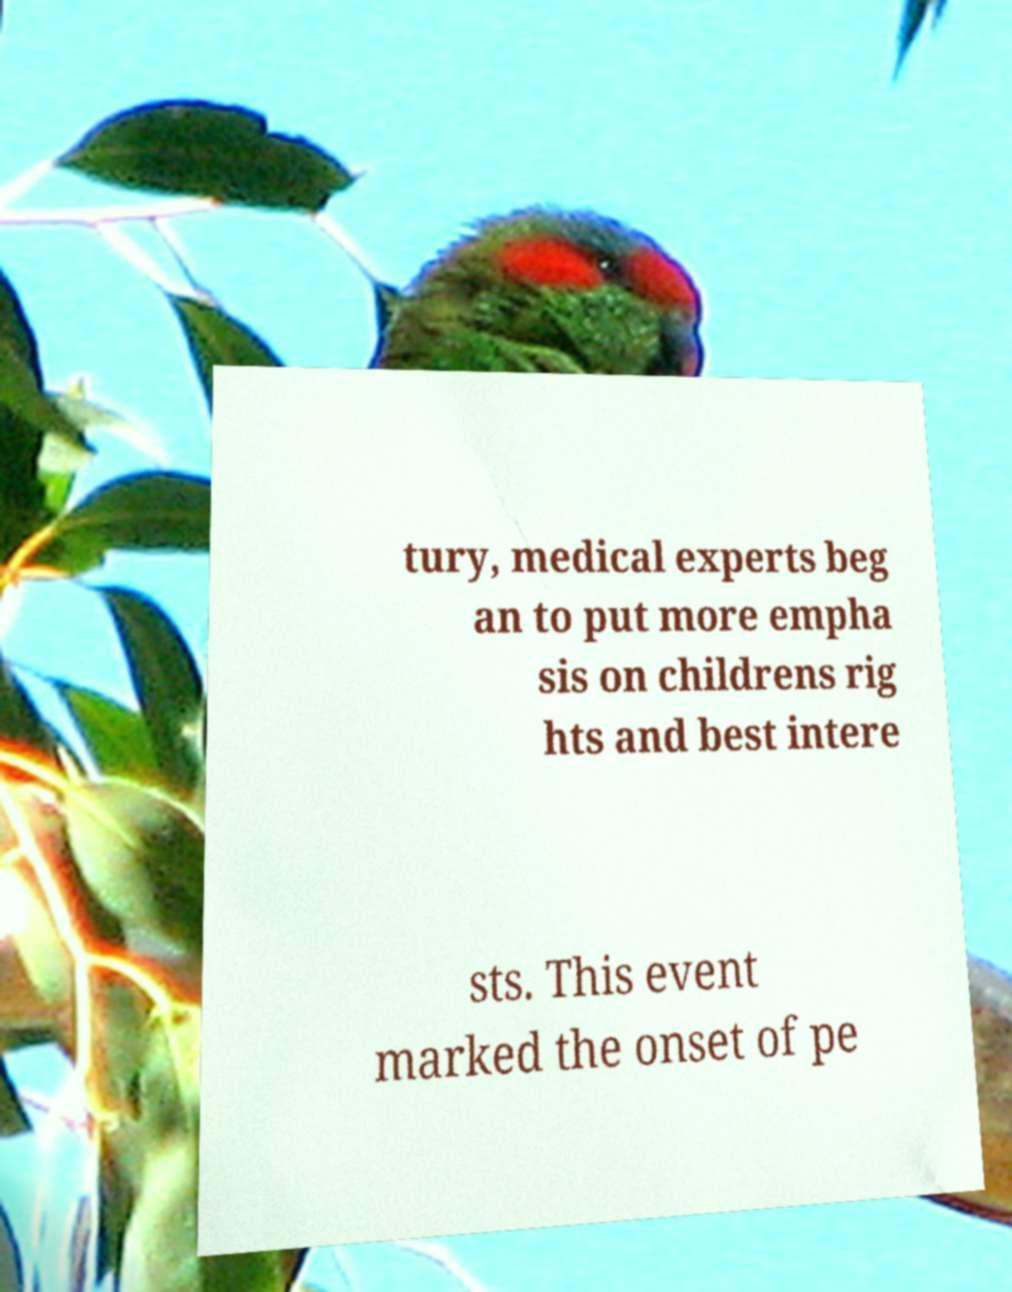Please read and relay the text visible in this image. What does it say? tury, medical experts beg an to put more empha sis on childrens rig hts and best intere sts. This event marked the onset of pe 